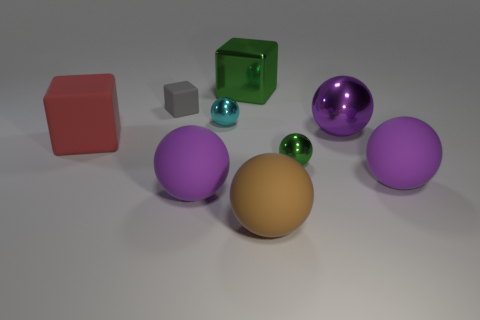There is a small metallic sphere that is in front of the red thing; is its color the same as the big metal block?
Offer a terse response. Yes. There is a small object in front of the big red object; is it the same color as the big metal thing that is to the left of the tiny green thing?
Give a very brief answer. Yes. Is there a small thing of the same color as the big metallic cube?
Offer a very short reply. Yes. There is a metallic sphere that is the same size as the brown matte object; what is its color?
Your response must be concise. Purple. What is the color of the large matte sphere that is on the left side of the large purple metal object and behind the brown matte ball?
Ensure brevity in your answer.  Purple. There is a shiny object that is the same color as the big shiny cube; what is its size?
Offer a very short reply. Small. What shape is the thing that is the same color as the metal cube?
Make the answer very short. Sphere. What is the size of the green metallic thing that is in front of the rubber object behind the cyan object that is in front of the gray matte object?
Give a very brief answer. Small. What is the big green block made of?
Your response must be concise. Metal. Do the green ball and the large purple ball that is to the left of the large brown matte ball have the same material?
Offer a terse response. No. 